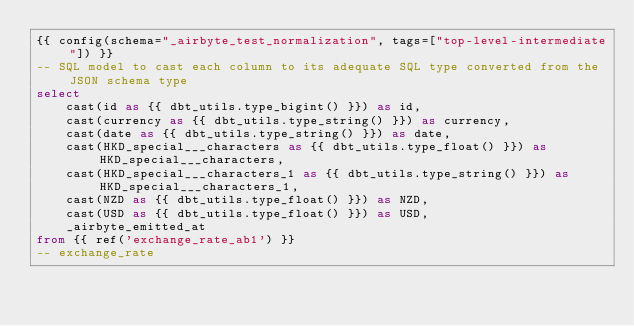Convert code to text. <code><loc_0><loc_0><loc_500><loc_500><_SQL_>{{ config(schema="_airbyte_test_normalization", tags=["top-level-intermediate"]) }}
-- SQL model to cast each column to its adequate SQL type converted from the JSON schema type
select
    cast(id as {{ dbt_utils.type_bigint() }}) as id,
    cast(currency as {{ dbt_utils.type_string() }}) as currency,
    cast(date as {{ dbt_utils.type_string() }}) as date,
    cast(HKD_special___characters as {{ dbt_utils.type_float() }}) as HKD_special___characters,
    cast(HKD_special___characters_1 as {{ dbt_utils.type_string() }}) as HKD_special___characters_1,
    cast(NZD as {{ dbt_utils.type_float() }}) as NZD,
    cast(USD as {{ dbt_utils.type_float() }}) as USD,
    _airbyte_emitted_at
from {{ ref('exchange_rate_ab1') }}
-- exchange_rate

</code> 